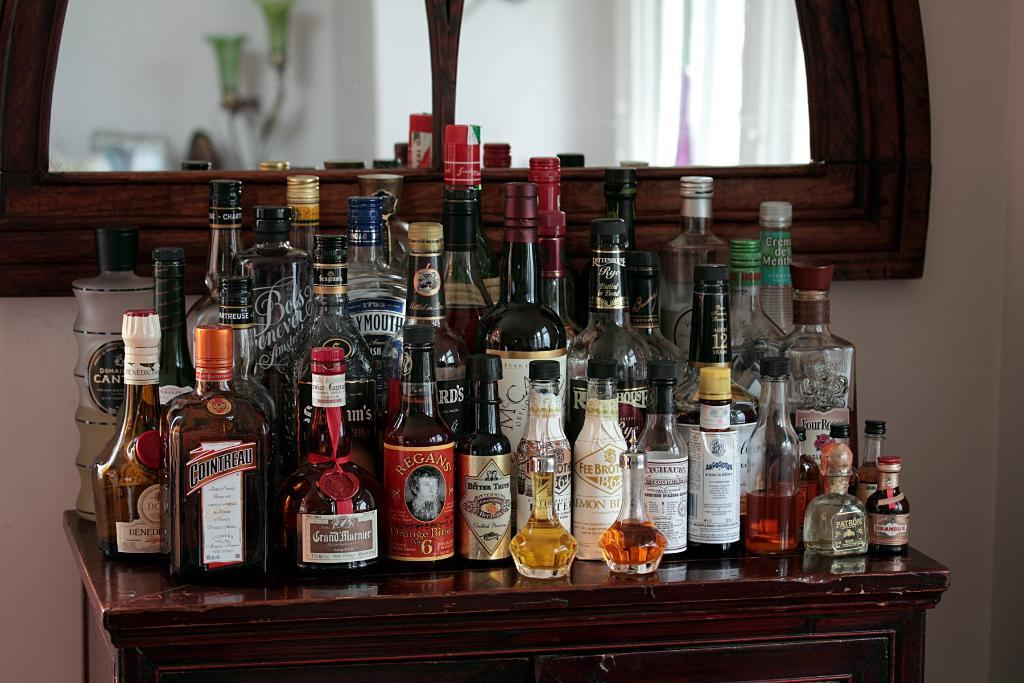<image>
Describe the image concisely. many bottles of liquor are on a wood table including Cointreau 